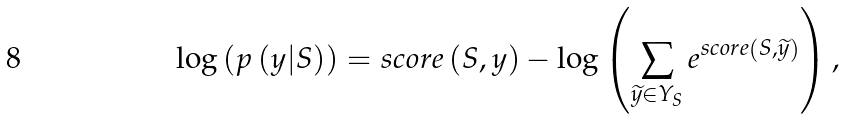<formula> <loc_0><loc_0><loc_500><loc_500>\log \left ( p \left ( y | S \right ) \right ) = s c o r e \left ( S , y \right ) - \log \left ( \sum _ { \widetilde { y } \in Y _ { S } } e ^ { s c o r e \left ( S , \widetilde { y } \right ) } \right ) ,</formula> 